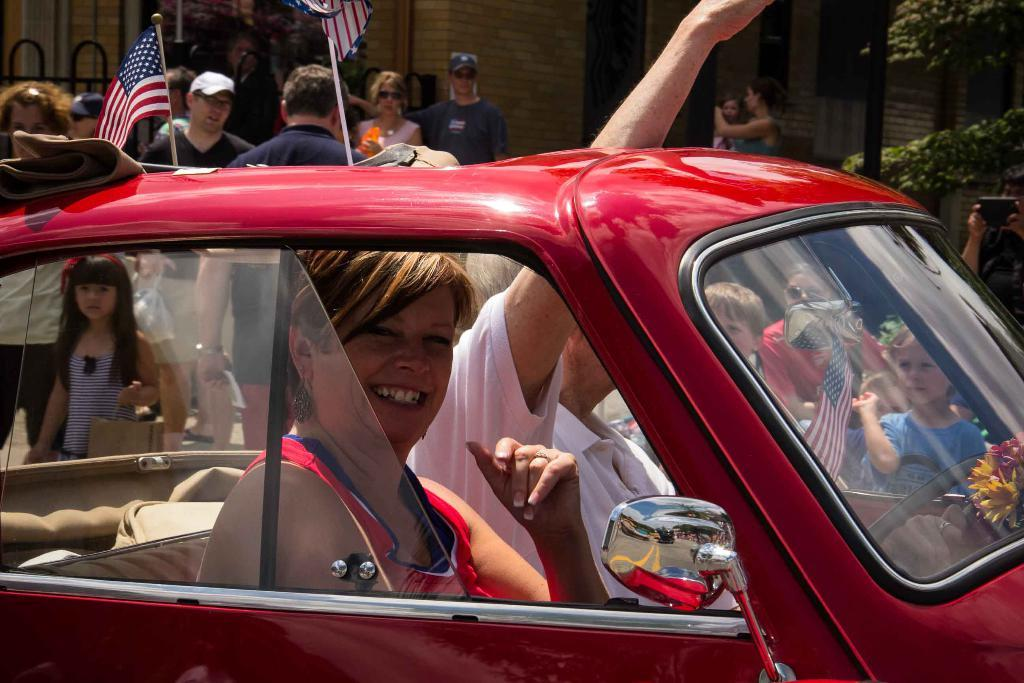Who or what is present in the image? There are people in the image. What type of vehicle can be seen in the image? There is a car in the image. What is the symbolic object in the image? There is a flag in the image. What type of structure is visible in the image? There is a building in the image. What type of plant is present in the image? There is a tree in the image. In which direction are the people in the image laughing at the earth? There is no indication in the image that the people are laughing or that the earth is present. 